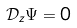<formula> <loc_0><loc_0><loc_500><loc_500>\mathcal { D } _ { z } \Psi = 0</formula> 